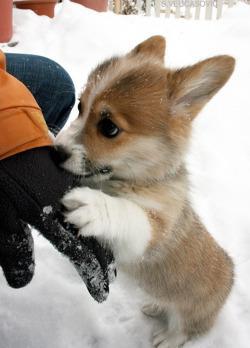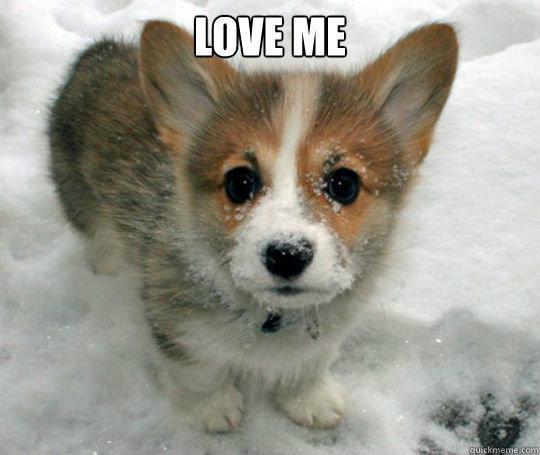The first image is the image on the left, the second image is the image on the right. Analyze the images presented: Is the assertion "There are 3 dogs." valid? Answer yes or no. No. 